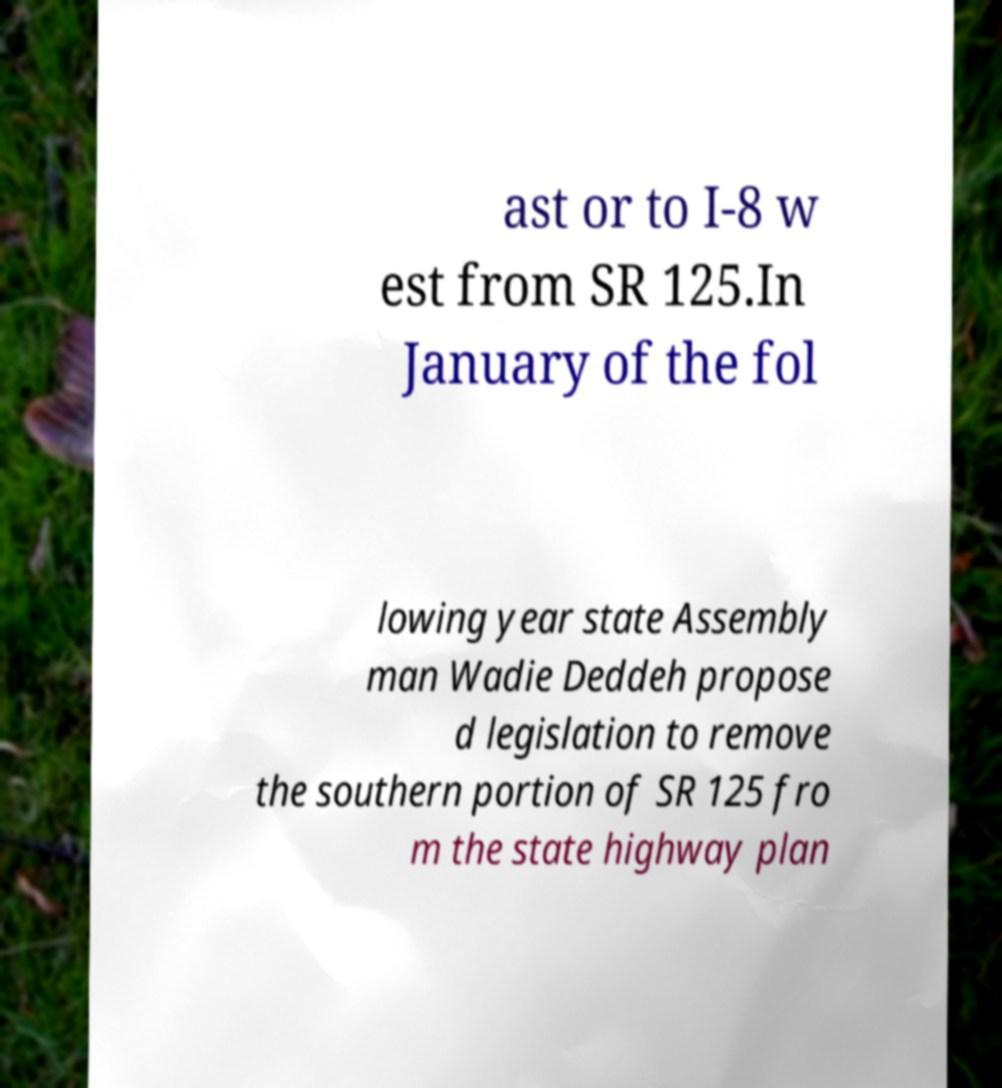Could you extract and type out the text from this image? ast or to I-8 w est from SR 125.In January of the fol lowing year state Assembly man Wadie Deddeh propose d legislation to remove the southern portion of SR 125 fro m the state highway plan 